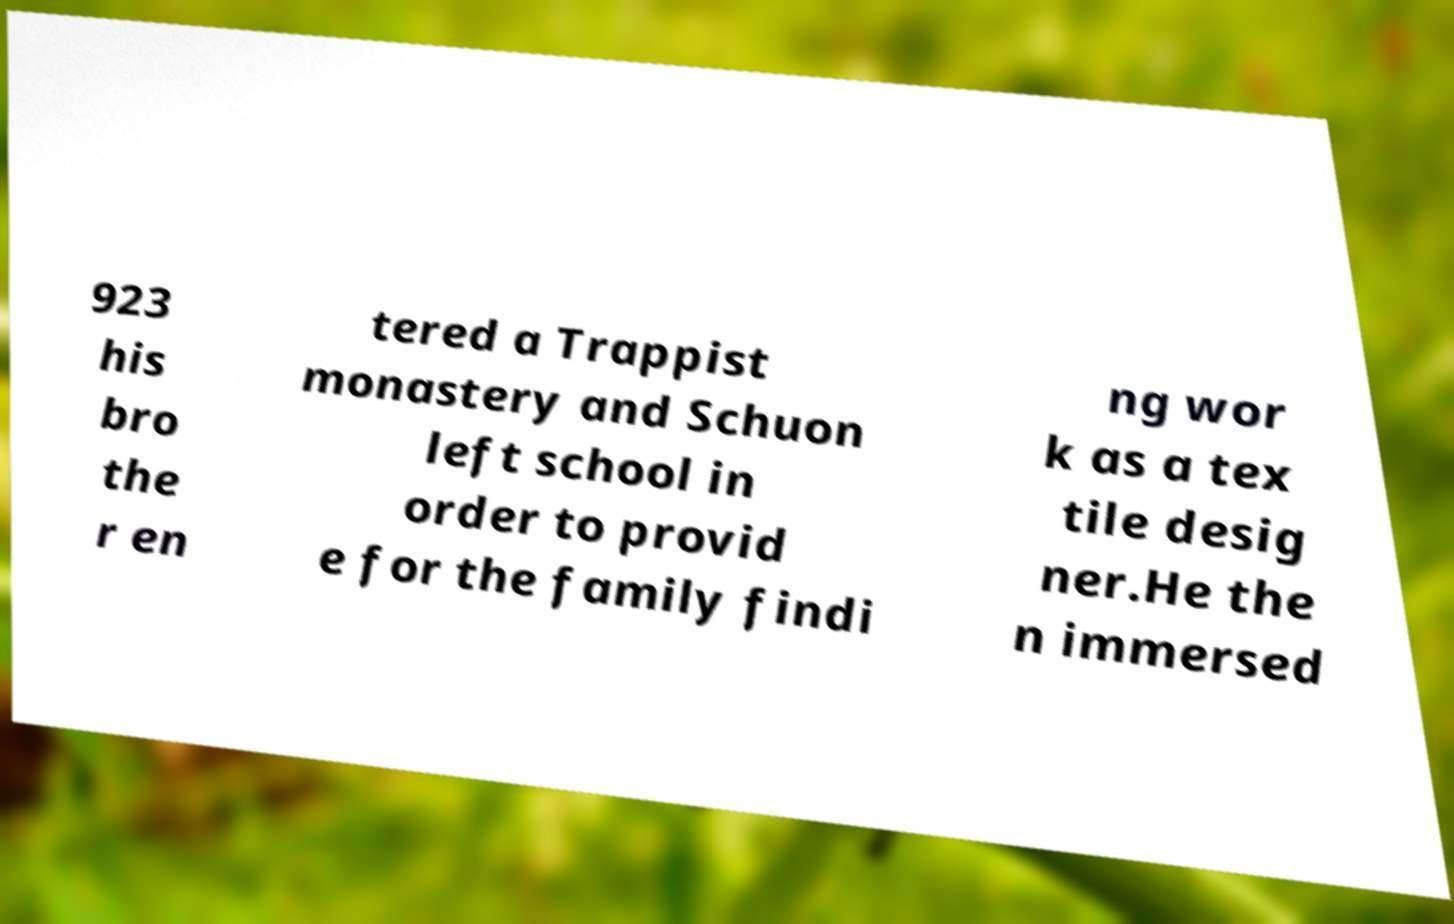For documentation purposes, I need the text within this image transcribed. Could you provide that? 923 his bro the r en tered a Trappist monastery and Schuon left school in order to provid e for the family findi ng wor k as a tex tile desig ner.He the n immersed 